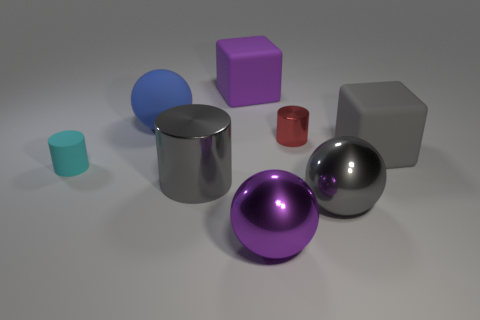Add 2 tiny brown matte cubes. How many objects exist? 10 Subtract all blocks. How many objects are left? 6 Add 6 gray matte cubes. How many gray matte cubes exist? 7 Subtract 1 purple spheres. How many objects are left? 7 Subtract all big rubber cylinders. Subtract all blue matte objects. How many objects are left? 7 Add 4 big cylinders. How many big cylinders are left? 5 